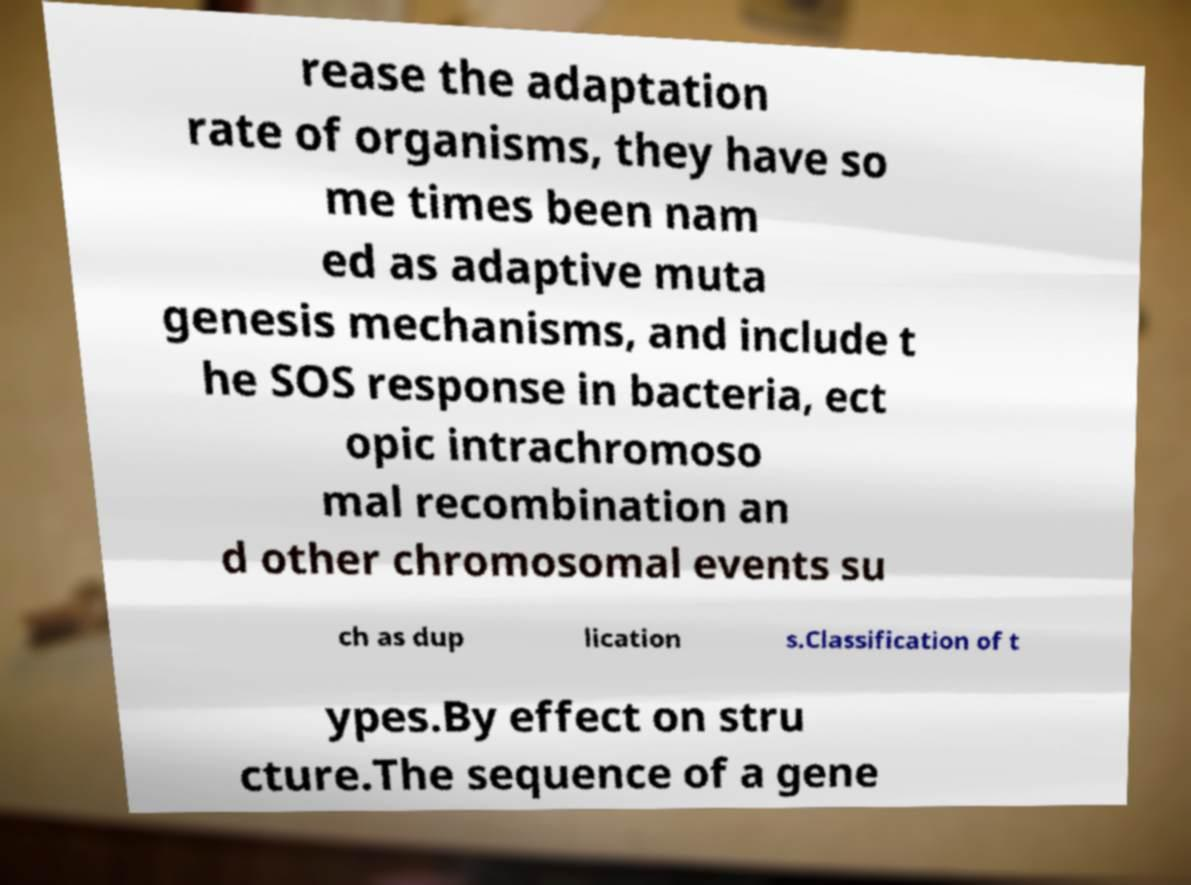Please identify and transcribe the text found in this image. rease the adaptation rate of organisms, they have so me times been nam ed as adaptive muta genesis mechanisms, and include t he SOS response in bacteria, ect opic intrachromoso mal recombination an d other chromosomal events su ch as dup lication s.Classification of t ypes.By effect on stru cture.The sequence of a gene 